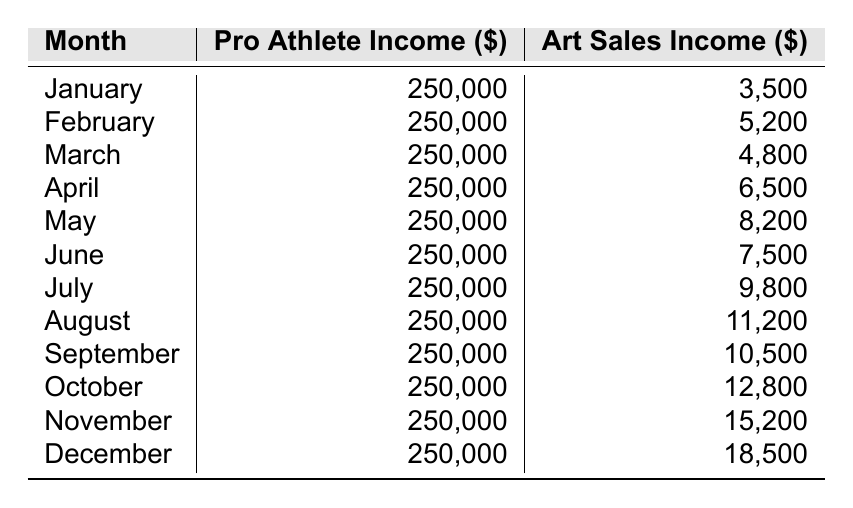What is the Pro Athlete Income in November? In the table, I can find the entry for November, which shows the Pro Athlete Income as 250,000.
Answer: 250,000 What is the Art Sales Income for July? The table lists July's Art Sales Income as 9,800.
Answer: 9,800 In which month did the Art Sales Income exceed 10,000? By scanning the table, I see that the Art Sales Income exceeded 10,000 starting from August, where it is 11,200.
Answer: August What is the difference in income between Pro Athlete Income and Art Sales Income in December? For December, the Pro Athlete Income is 250,000 and the Art Sales Income is 18,500. The difference is calculated as 250,000 - 18,500 = 231,500.
Answer: 231,500 What is the average Art Sales Income for the first half of the year (January to June)? To find the average, I sum the Art Sales Incomes: 3,500 + 5,200 + 4,800 + 6,500 + 8,200 + 7,500 = 35,700. Then I divide by 6 (the number of months): 35,700 / 6 = 5,950.
Answer: 5,950 Is the Art Sales Income consistent every month? Reviewing the table shows varying numbers for each month, indicating that the Art Sales Income is not consistent.
Answer: No In which month was the highest Art Sales Income achieved, and what was that amount? By looking through the table, December shows the highest Art Sales Income of 18,500.
Answer: December, 18,500 If I add the Art Sales Income for March and May, what is the total? March shows 4,800 and May shows 8,200. Adding these amounts gives: 4,800 + 8,200 = 13,000.
Answer: 13,000 How much more does a Pro Athlete earn compared to an artist on average each month? The Pro Athlete earns a constant 250,000, while the average Art Sales Income can be computed as (3,500 + 5,200 + 4,800 + 6,500 + 8,200 + 7,500 + 9,800 + 11,200 + 10,500 + 12,800 + 15,200 + 18,500) / 12 = 9,350. Hence, the difference is 250,000 - 9,350 = 240,650.
Answer: 240,650 During which month did Art Sales Income experience the largest increase from the previous month, and what was the increase? By checking the table, the largest increase occurs from November to December, where the income went from 15,200 to 18,500. The increase is 18,500 - 15,200 = 3,300.
Answer: December, 3,300 What is the total Art Sales Income for the entire year? To find the total, I sum all the monthly incomes: 3,500 + 5,200 + 4,800 + 6,500 + 8,200 + 7,500 + 9,800 + 11,200 + 10,500 + 12,800 + 15,200 + 18,500 =  120,000.
Answer: 120,000 